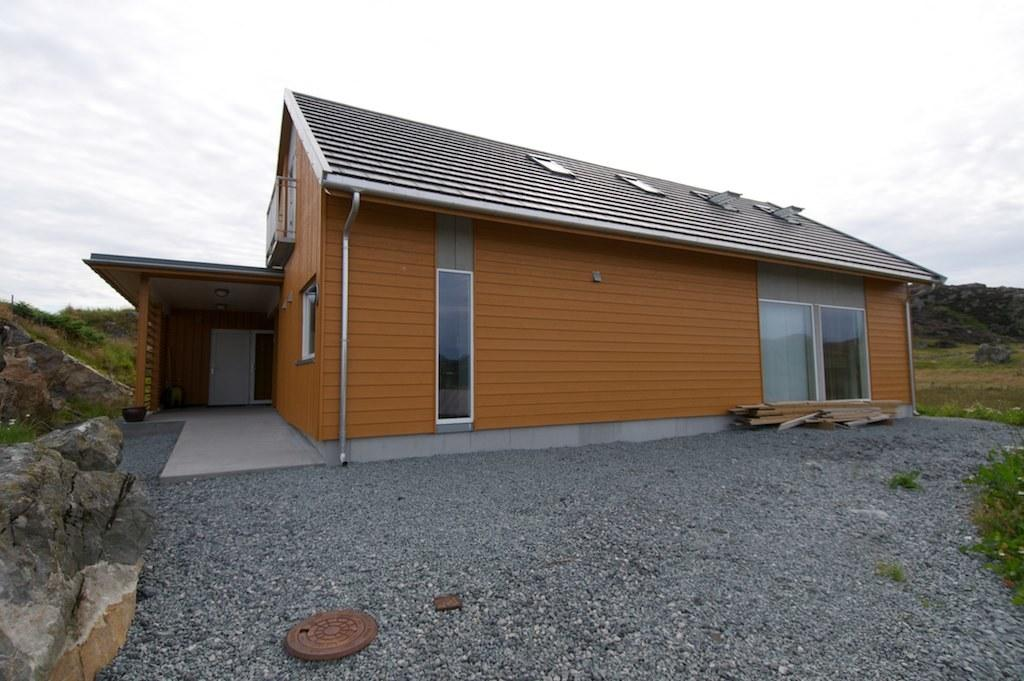What type of structure can be seen in the image? There is a shed in the image. What natural elements are present in the image? There are rocks and grass visible in the image. What is visible in the background of the image? The sky is visible in the background of the image. What type of ground surface is depicted in the image? There are stones at the bottom of the image. What type of wine is being served at the street event in the image? There is no street event or wine present in the image; it features a shed, rocks, grass, and stones. 